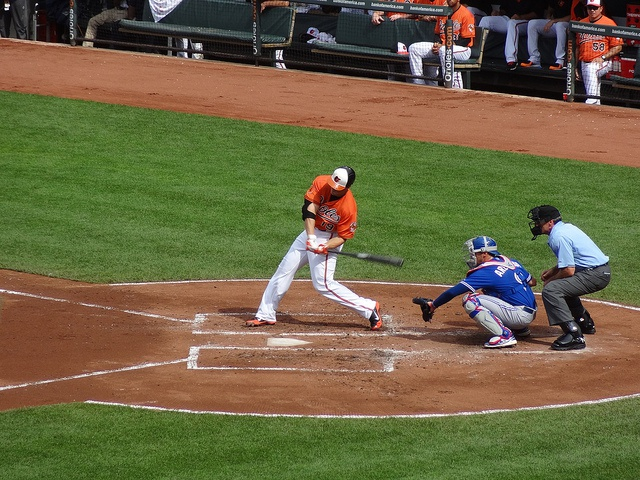Describe the objects in this image and their specific colors. I can see people in black, lavender, brown, darkgray, and maroon tones, people in black, lightgray, navy, and blue tones, people in black, gray, and lightblue tones, people in black, lightgray, gray, and darkgray tones, and people in black, lavender, maroon, and red tones in this image. 